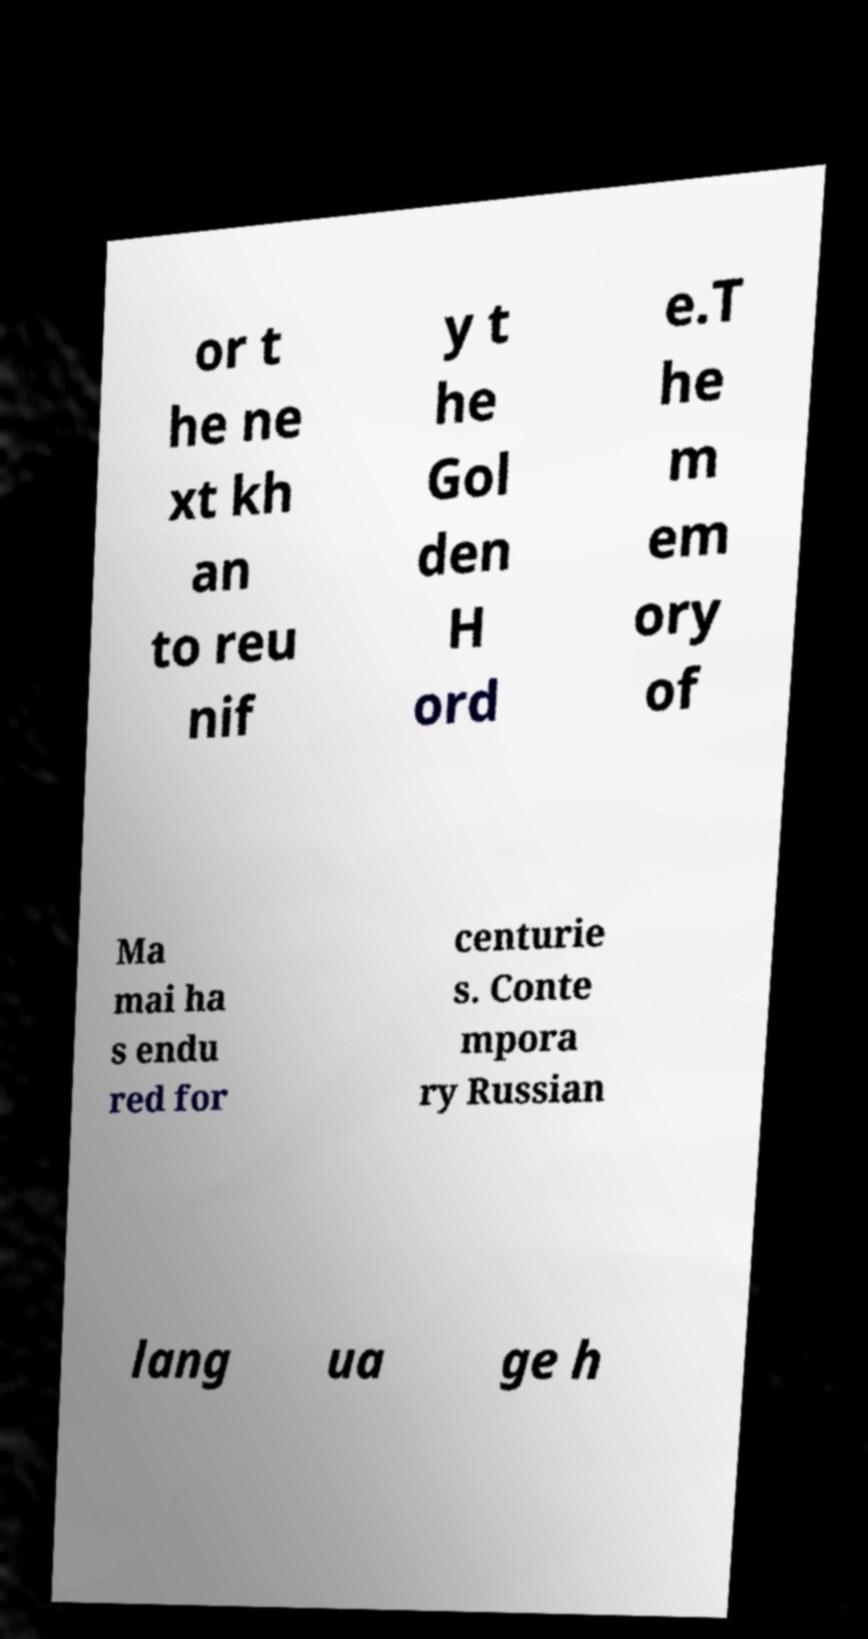Can you read and provide the text displayed in the image?This photo seems to have some interesting text. Can you extract and type it out for me? or t he ne xt kh an to reu nif y t he Gol den H ord e.T he m em ory of Ma mai ha s endu red for centurie s. Conte mpora ry Russian lang ua ge h 